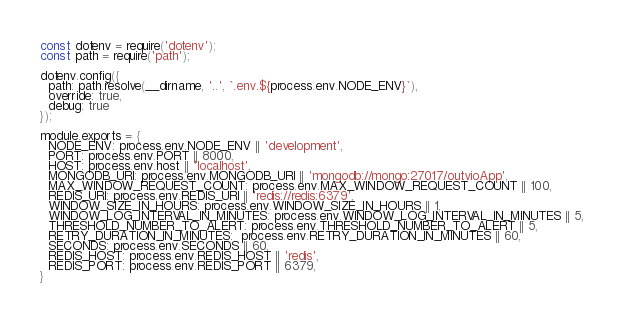Convert code to text. <code><loc_0><loc_0><loc_500><loc_500><_JavaScript_>const dotenv = require('dotenv');
const path = require('path');

dotenv.config({
  path: path.resolve(__dirname, '..', `.env.${process.env.NODE_ENV}`),
  override: true,
  debug: true
});

module.exports = {
  NODE_ENV: process.env.NODE_ENV || 'development',
  PORT: process.env.PORT || 8000,
  HOST: process.env.host || 'localhost',
  MONGODB_URI: process.env.MONGODB_URI || 'mongodb://mongo:27017/outvioApp',
  MAX_WINDOW_REQUEST_COUNT: process.env.MAX_WINDOW_REQUEST_COUNT || 100,
  REDIS_URI: process.env.REDIS_URI || 'redis://redis:6379',
  WINDOW_SIZE_IN_HOURS: process.env.WINDOW_SIZE_IN_HOURS || 1,
  WINDOW_LOG_INTERVAL_IN_MINUTES: process.env.WINDOW_LOG_INTERVAL_IN_MINUTES || 5,
  THRESHOLD_NUMBER_TO_ALERT: process.env.THRESHOLD_NUMBER_TO_ALERT || 5,
  RETRY_DURATION_IN_MINUTES:  process.env.RETRY_DURATION_IN_MINUTES || 60,
  SECONDS: process.env.SECONDS || 60,
  REDIS_HOST: process.env.REDIS_HOST || 'redis',
  REDIS_PORT: process.env.REDIS_PORT || 6379,
}
</code> 